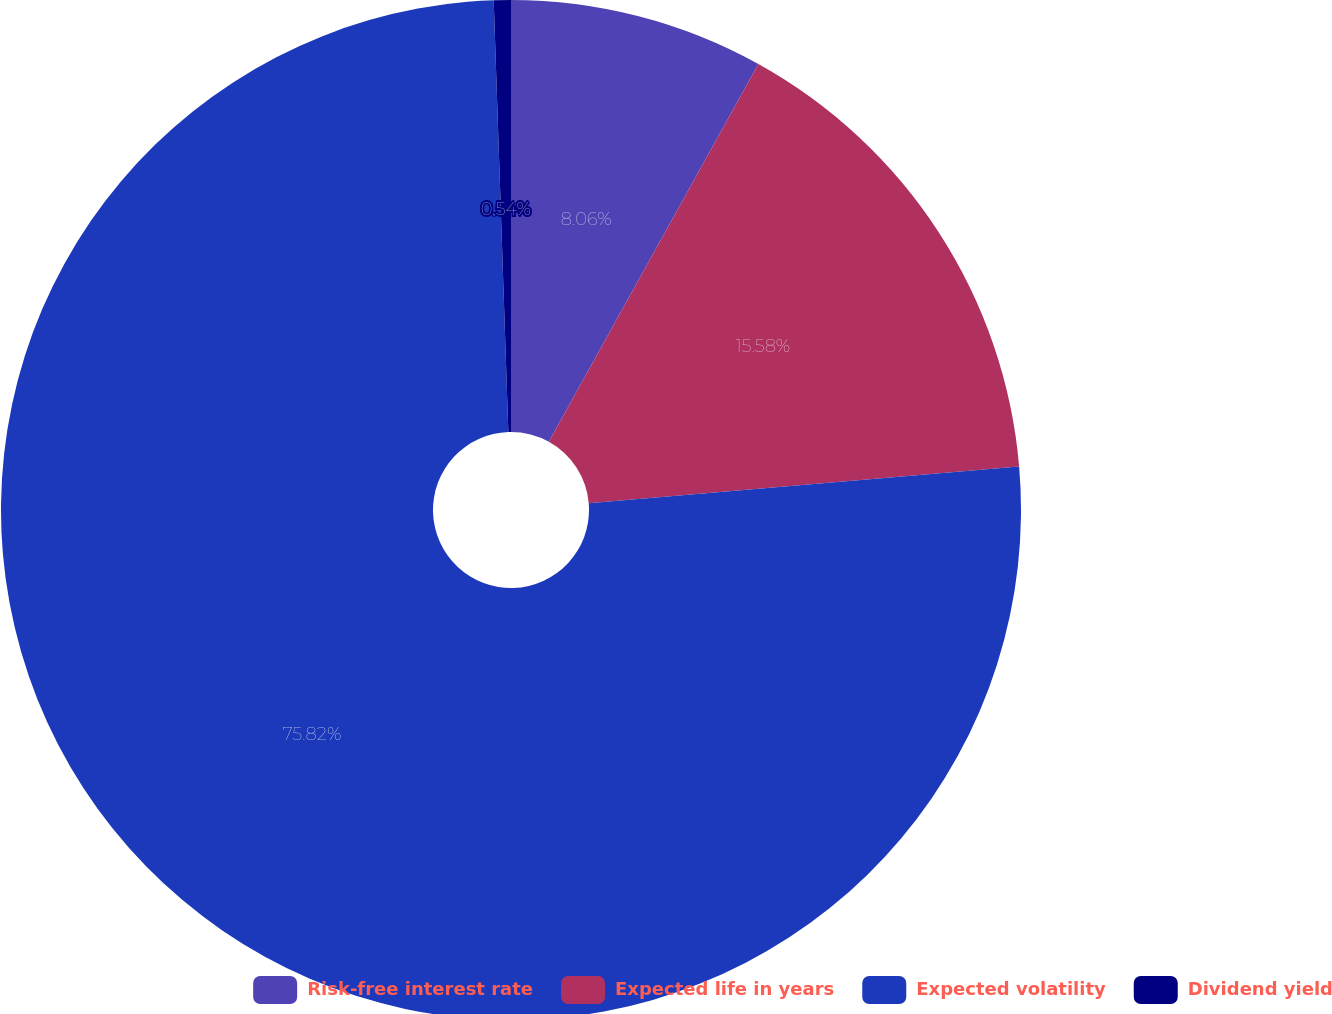<chart> <loc_0><loc_0><loc_500><loc_500><pie_chart><fcel>Risk-free interest rate<fcel>Expected life in years<fcel>Expected volatility<fcel>Dividend yield<nl><fcel>8.06%<fcel>15.58%<fcel>75.82%<fcel>0.54%<nl></chart> 